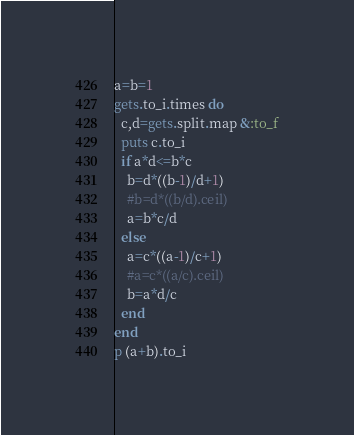Convert code to text. <code><loc_0><loc_0><loc_500><loc_500><_Ruby_>a=b=1
gets.to_i.times do
  c,d=gets.split.map &:to_f
  puts c.to_i
  if a*d<=b*c
    b=d*((b-1)/d+1)
    #b=d*((b/d).ceil)
    a=b*c/d
  else
    a=c*((a-1)/c+1)
    #a=c*((a/c).ceil)
    b=a*d/c
  end
end
p (a+b).to_i</code> 